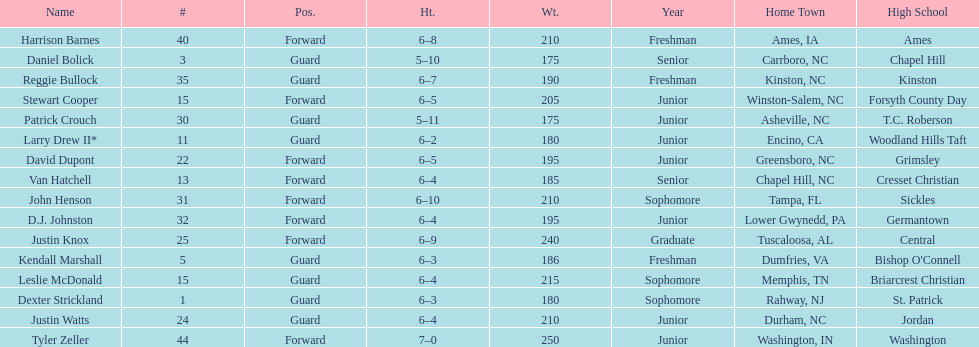Who was taller, justin knox or john henson? John Henson. 